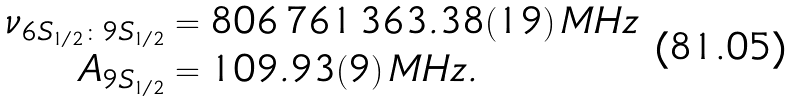<formula> <loc_0><loc_0><loc_500><loc_500>\nu _ { 6 S _ { 1 / 2 } \colon 9 S _ { 1 / 2 } } & = 8 0 6 \, 7 6 1 \, 3 6 3 . 3 8 ( 1 9 ) \, M H z \\ A _ { 9 S _ { 1 / 2 } } & = 1 0 9 . 9 3 ( 9 ) \, M H z .</formula> 